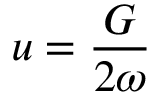Convert formula to latex. <formula><loc_0><loc_0><loc_500><loc_500>u = \frac { G } { 2 \omega }</formula> 